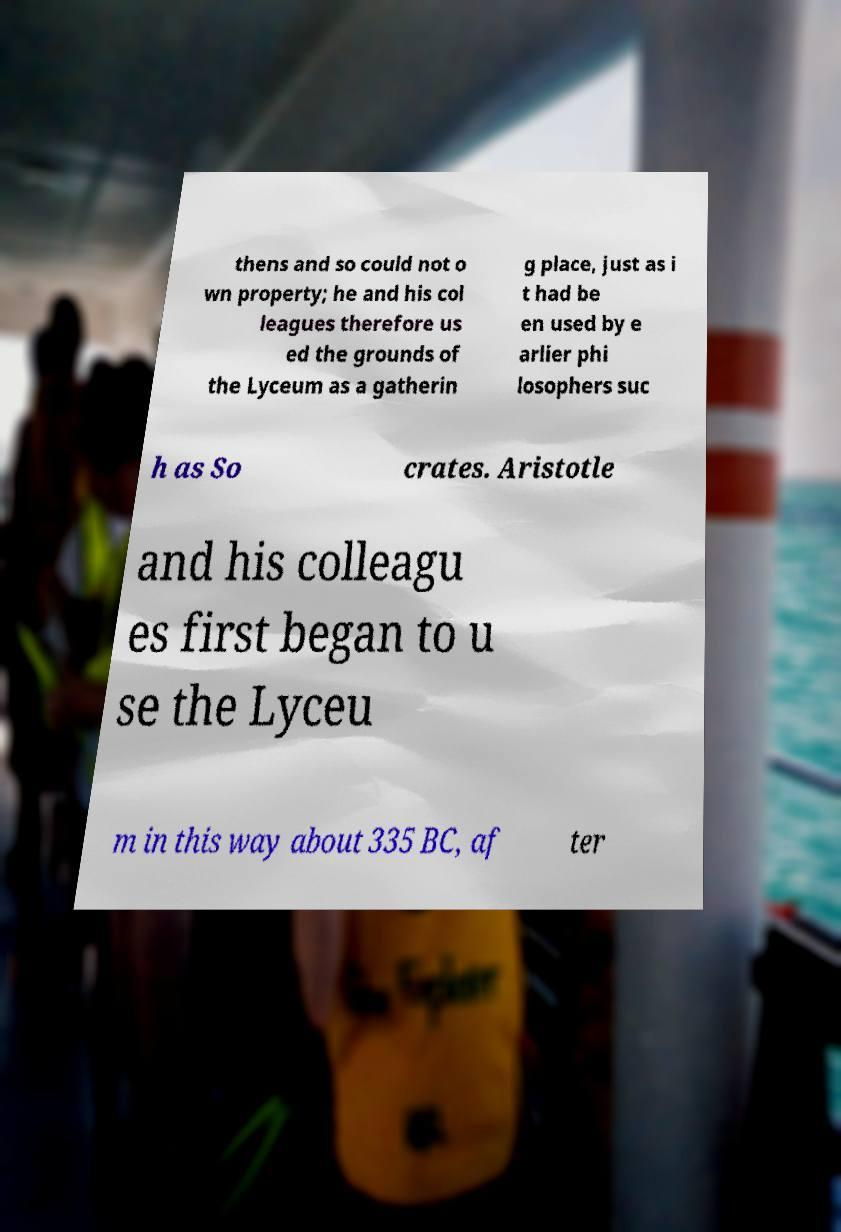Can you read and provide the text displayed in the image?This photo seems to have some interesting text. Can you extract and type it out for me? thens and so could not o wn property; he and his col leagues therefore us ed the grounds of the Lyceum as a gatherin g place, just as i t had be en used by e arlier phi losophers suc h as So crates. Aristotle and his colleagu es first began to u se the Lyceu m in this way about 335 BC, af ter 